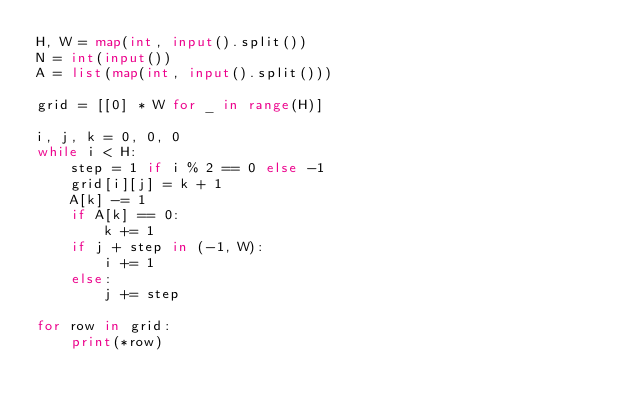Convert code to text. <code><loc_0><loc_0><loc_500><loc_500><_Python_>H, W = map(int, input().split())
N = int(input())
A = list(map(int, input().split()))

grid = [[0] * W for _ in range(H)]

i, j, k = 0, 0, 0
while i < H:
    step = 1 if i % 2 == 0 else -1
    grid[i][j] = k + 1
    A[k] -= 1
    if A[k] == 0:
        k += 1
    if j + step in (-1, W):
        i += 1
    else:
        j += step

for row in grid:
    print(*row)
</code> 